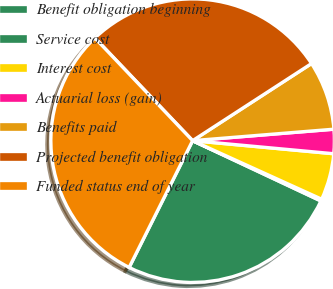Convert chart to OTSL. <chart><loc_0><loc_0><loc_500><loc_500><pie_chart><fcel>Benefit obligation beginning<fcel>Service cost<fcel>Interest cost<fcel>Actuarial loss (gain)<fcel>Benefits paid<fcel>Projected benefit obligation<fcel>Funded status end of year<nl><fcel>25.4%<fcel>0.21%<fcel>5.31%<fcel>2.76%<fcel>7.87%<fcel>27.95%<fcel>30.51%<nl></chart> 